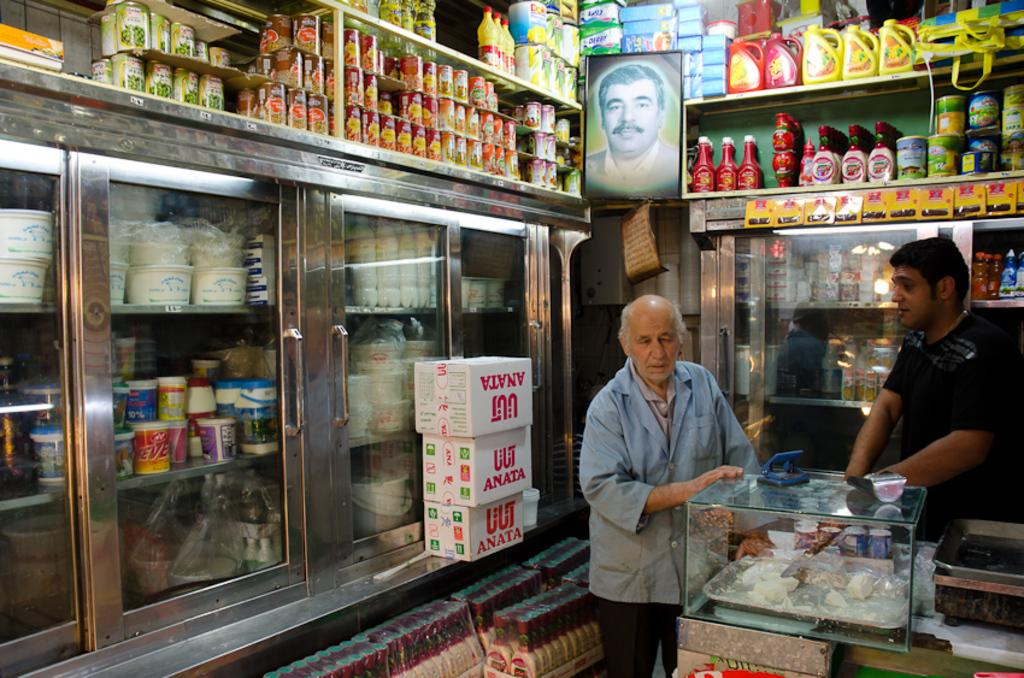How many people are present in the image? There are two people standing in the image. What surface are the people standing on? The people are standing on the floor. What can be seen in the background of the image? There are shelves with items in the background of the image, and a photo is between the shelves. What type of clouds can be seen in the image? There are no clouds visible in the image. Can you tell me how many forks are present in the image? There is no fork present in the image. 